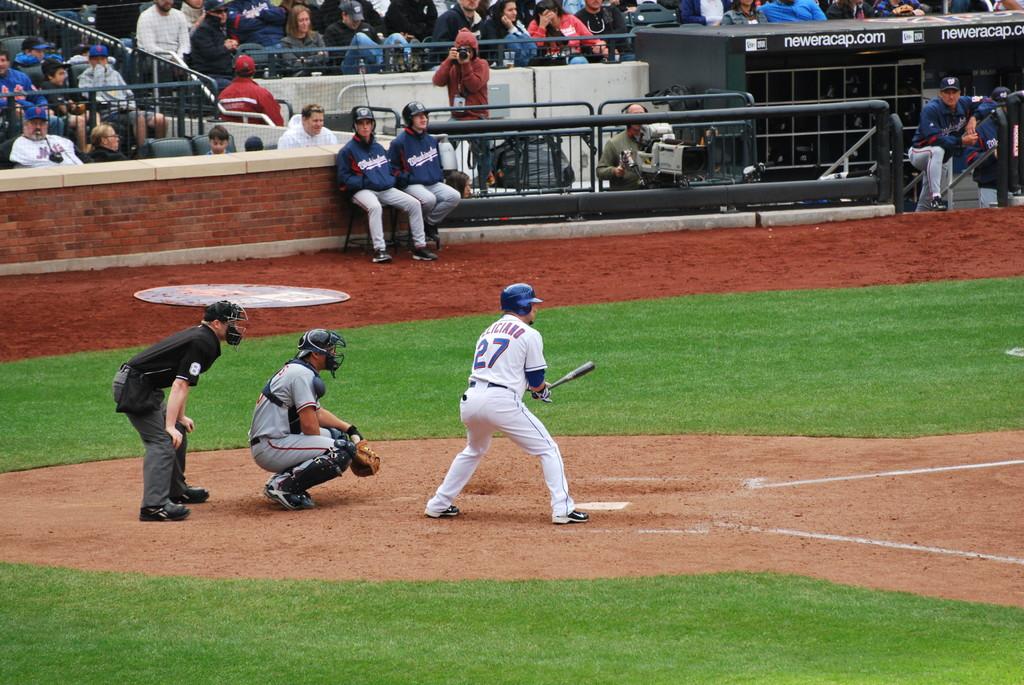What is the player's number?
Provide a succinct answer. 27. What is the number on the umpire's black shirt?
Ensure brevity in your answer.  8. 